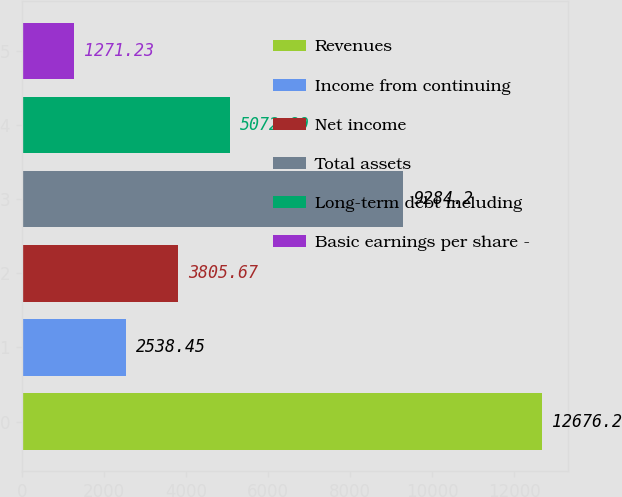<chart> <loc_0><loc_0><loc_500><loc_500><bar_chart><fcel>Revenues<fcel>Income from continuing<fcel>Net income<fcel>Total assets<fcel>Long-term debt including<fcel>Basic earnings per share -<nl><fcel>12676.2<fcel>2538.45<fcel>3805.67<fcel>9284.2<fcel>5072.89<fcel>1271.23<nl></chart> 